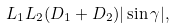Convert formula to latex. <formula><loc_0><loc_0><loc_500><loc_500>L _ { 1 } L _ { 2 } ( D _ { 1 } + D _ { 2 } ) | \sin \gamma | ,</formula> 